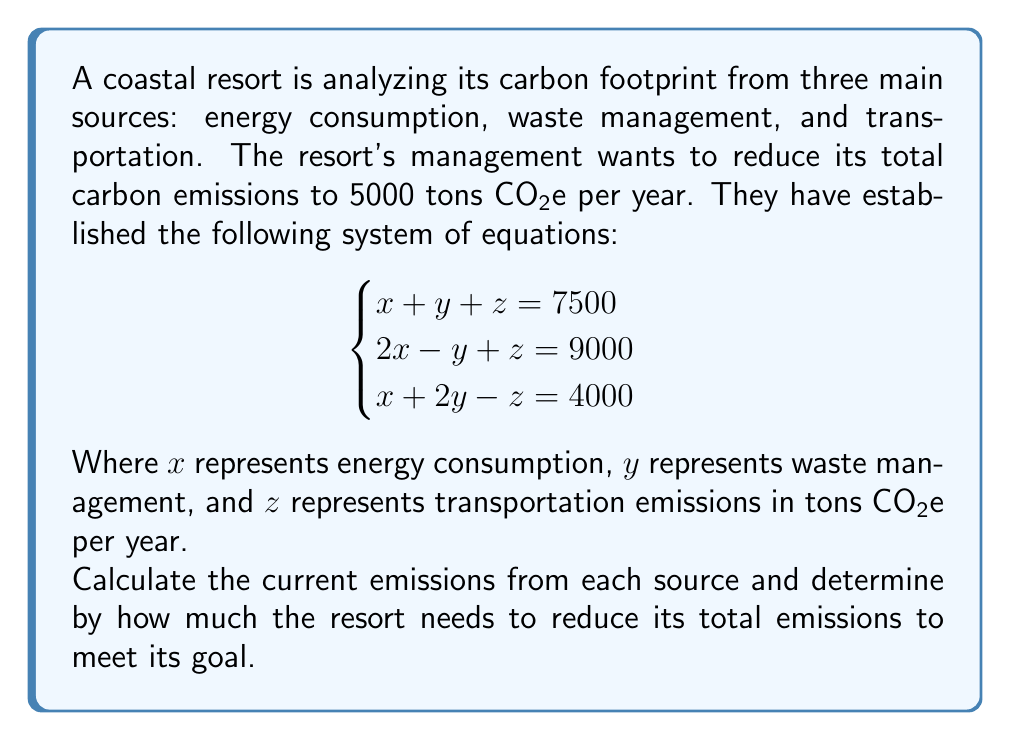Can you solve this math problem? To solve this system of linear equations, we'll use the elimination method:

1) From equation 1 and 2, eliminate y:
   $$(x + y + z = 7500) \cdot 2: 2x + 2y + 2z = 15000$$
   $$(2x - y + z = 9000) \cdot 1: 2x - y + z = 9000$$
   Subtracting: $3y + z = 6000$ (Equation 4)

2) From equation 1 and 3, eliminate x:
   $(x + y + z = 7500) \cdot 1: x + y + z = 7500$
   $(x + 2y - z = 4000) \cdot 1: x + 2y - z = 4000$
   Subtracting: $-y + 2z = 3500$ (Equation 5)

3) Multiply equation 5 by 3:
   $-3y + 6z = 10500$ (Equation 6)

4) Add equation 4 and 6:
   $7z = 16500$
   $z = 2357.14$ tons CO2e

5) Substitute z in equation 5:
   $-y + 2(2357.14) = 3500$
   $-y = -1214.28$
   $y = 1214.28$ tons CO2e

6) Substitute y and z in equation 1:
   $x + 1214.28 + 2357.14 = 7500$
   $x = 3928.58$ tons CO2e

Current emissions:
Energy consumption (x): 3928.58 tons CO2e
Waste management (y): 1214.28 tons CO2e
Transportation (z): 2357.14 tons CO2e

Total current emissions: $3928.58 + 1214.28 + 2357.14 = 7500$ tons CO2e

To reach the goal of 5000 tons CO2e, the resort needs to reduce emissions by:
$7500 - 5000 = 2500$ tons CO2e
Answer: The resort needs to reduce emissions by 2500 tons CO2e per year. 